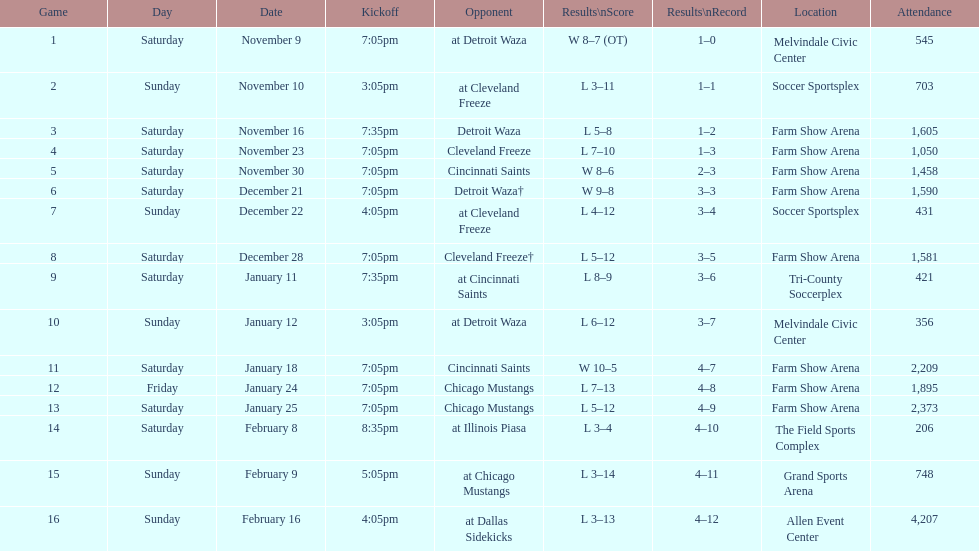For how long did the team's longest losing streak last? 5 games. 